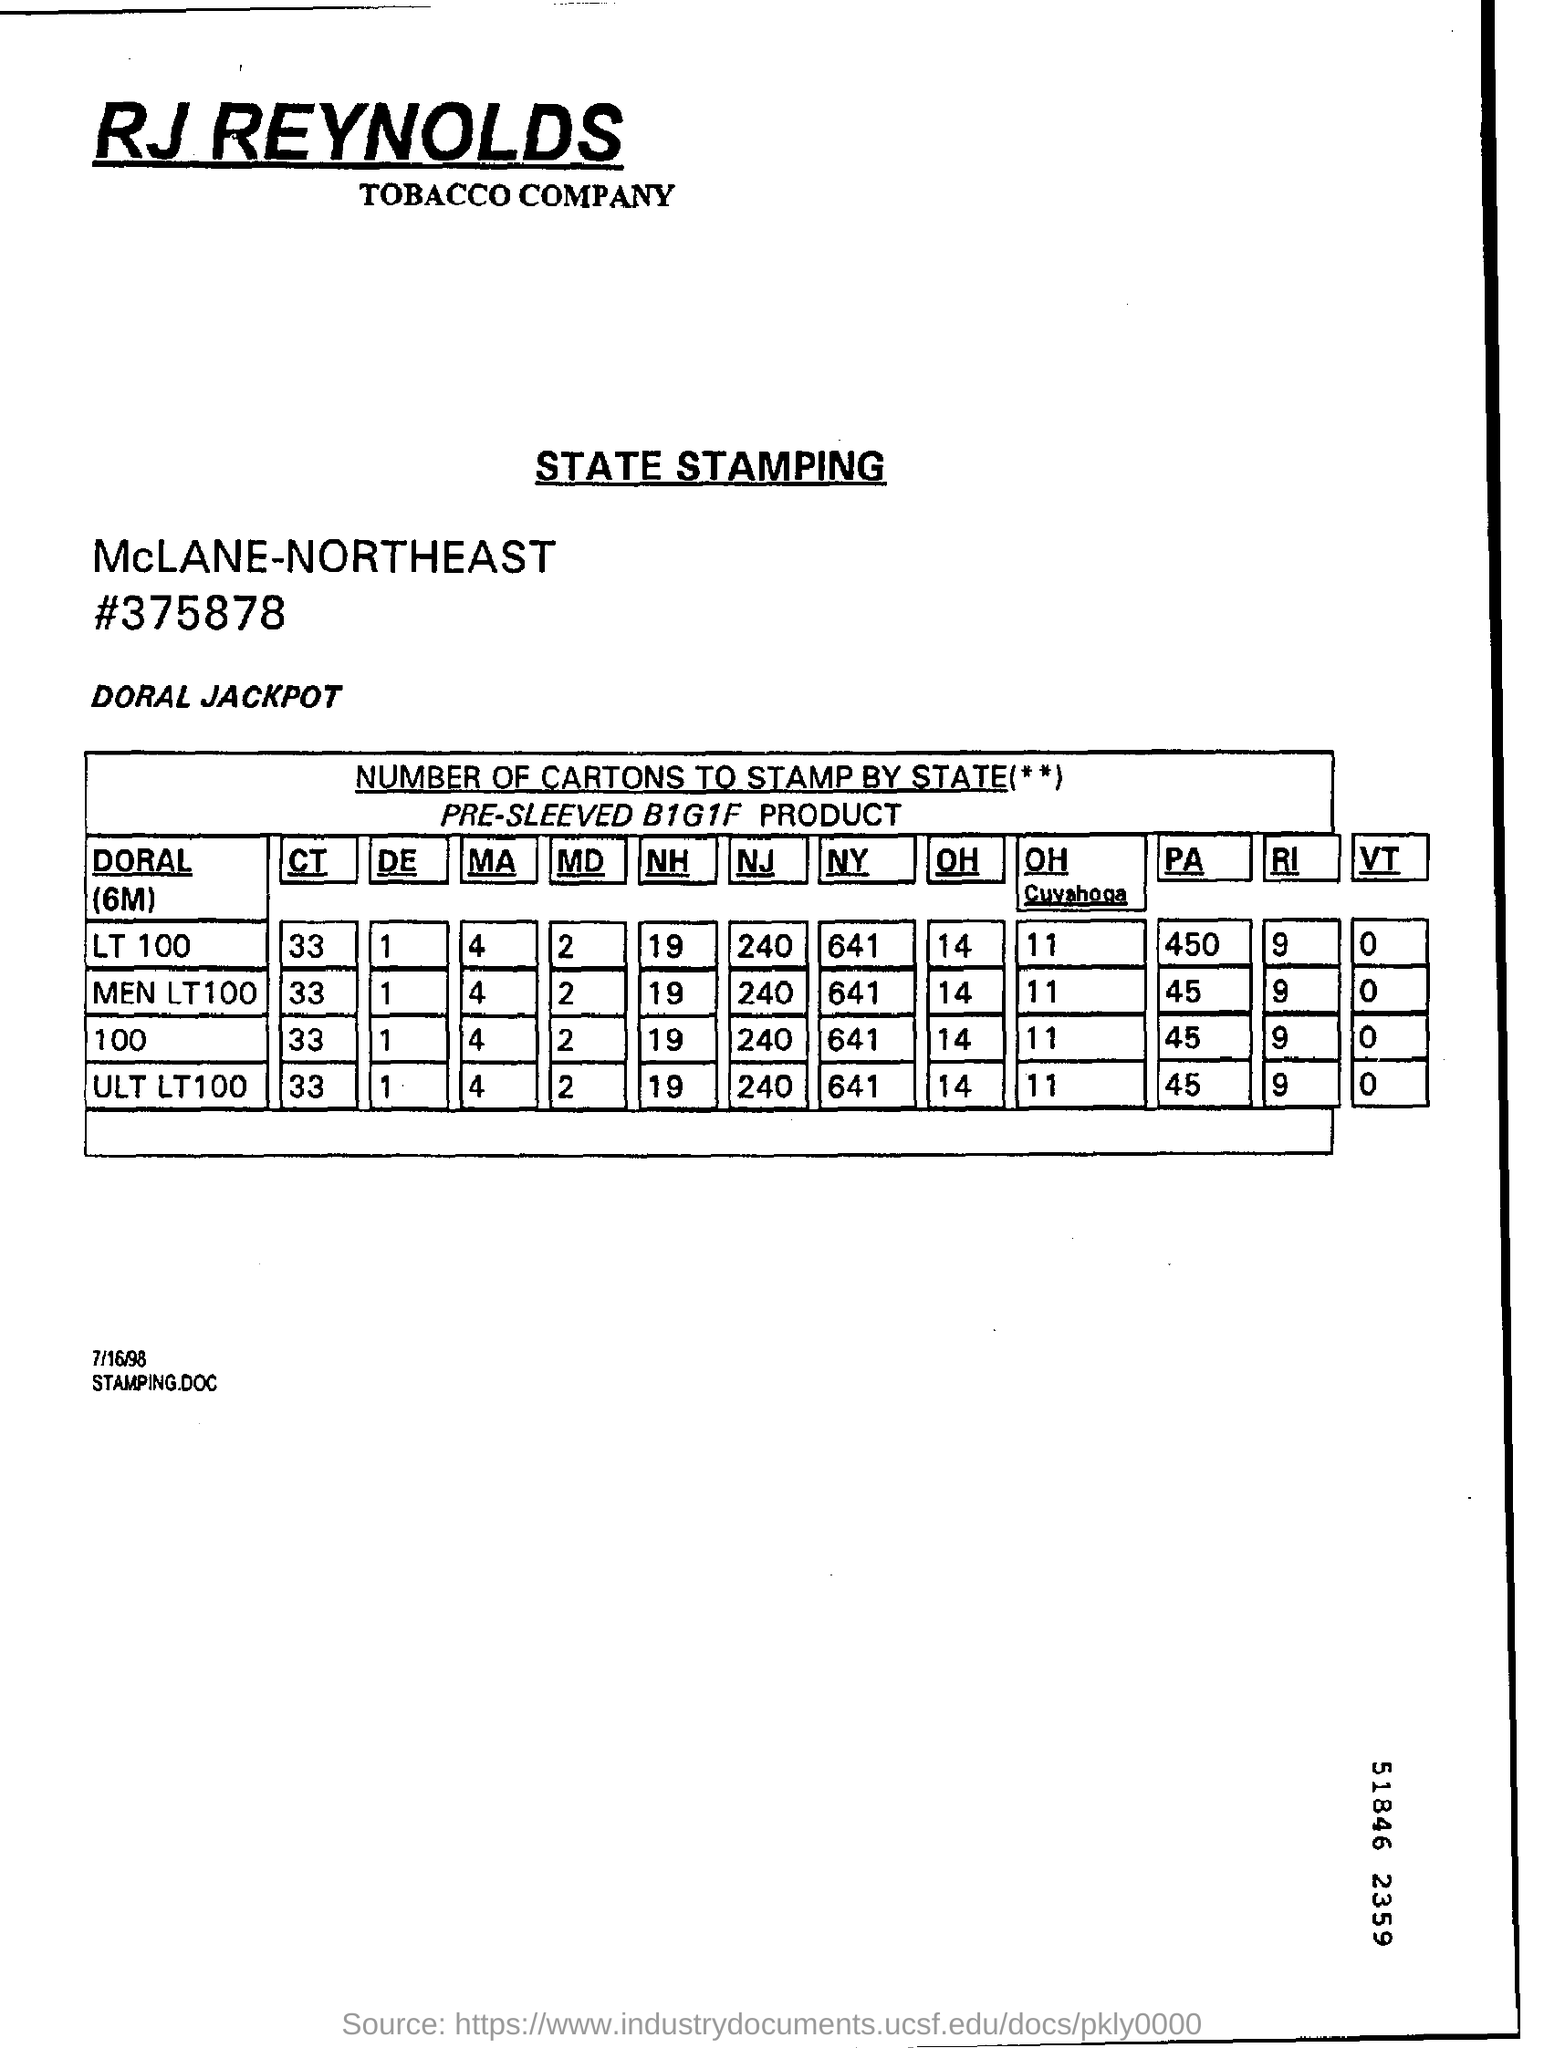Give some essential details in this illustration. The serial number on the state stamping document is #375878. There are 4 ULT LT 100s to be stamped in Massachusetts. The name of the tobacco company is RJ REYNOLDS. There are 641 LT 100 cartons that need to be stamped in New York. 